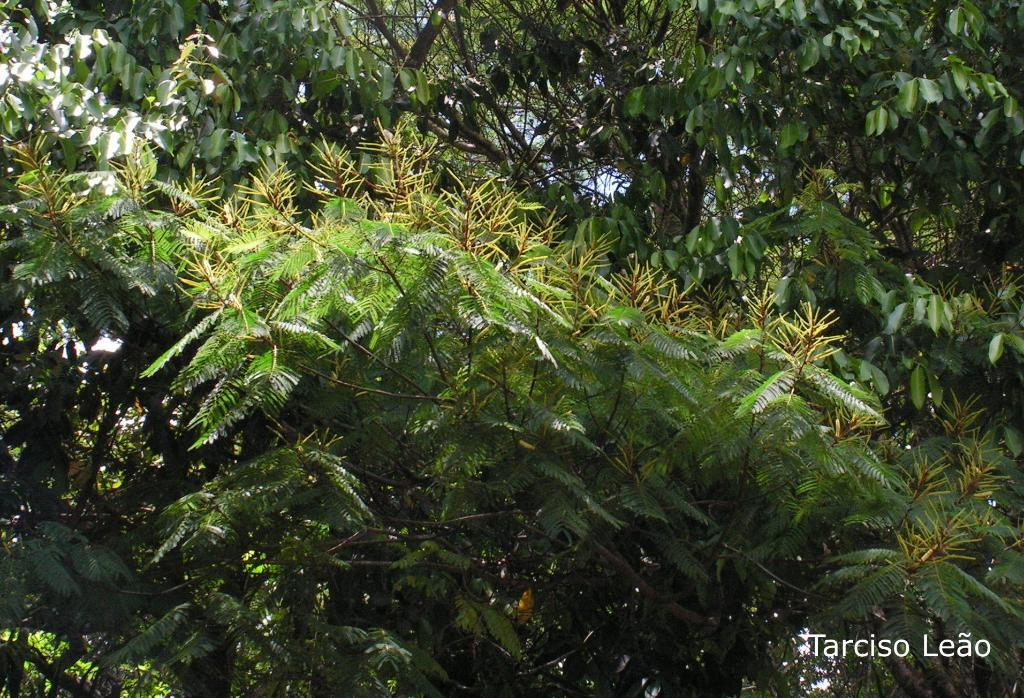What type of vegetation can be seen in the image? There are plants and trees in the image. Can you describe the plants and trees in more detail? Unfortunately, the facts provided do not give more specific details about the plants and trees. What might be the setting or location of the image based on the vegetation? Based on the presence of plants and trees, the image might be in a park or a natural setting. What type of prison can be seen in the image? There is no prison present in the image; it features plants and trees. What type of shame is associated with the plants in the image? There is no shame associated with the plants in the image; they are simply plants and trees. 